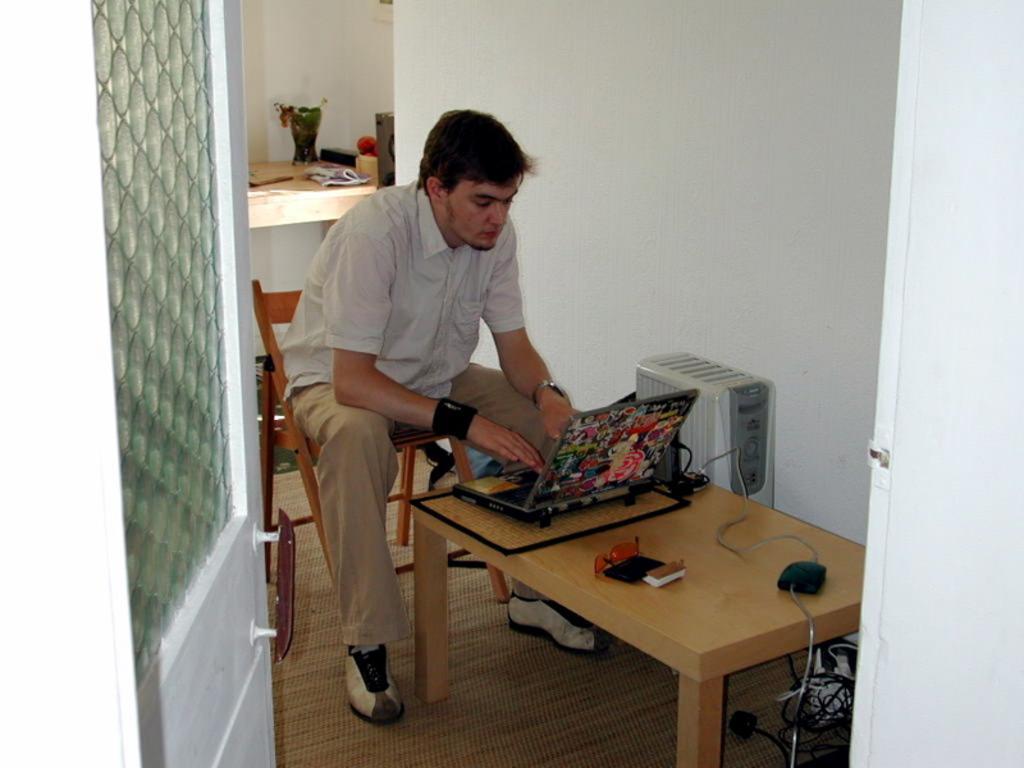Describe this image in one or two sentences. In the foreground of this image, there is a man sitting on the chair in front of a table on which, there is a laptop, spectacles, mobile, an object, adapter and the cable. On the bottom, there are cables. Beside the table, there is a device and the wall. On the left, there is a door. In the background, there is a table on which few objects are placed and on the top, there is the wall. 